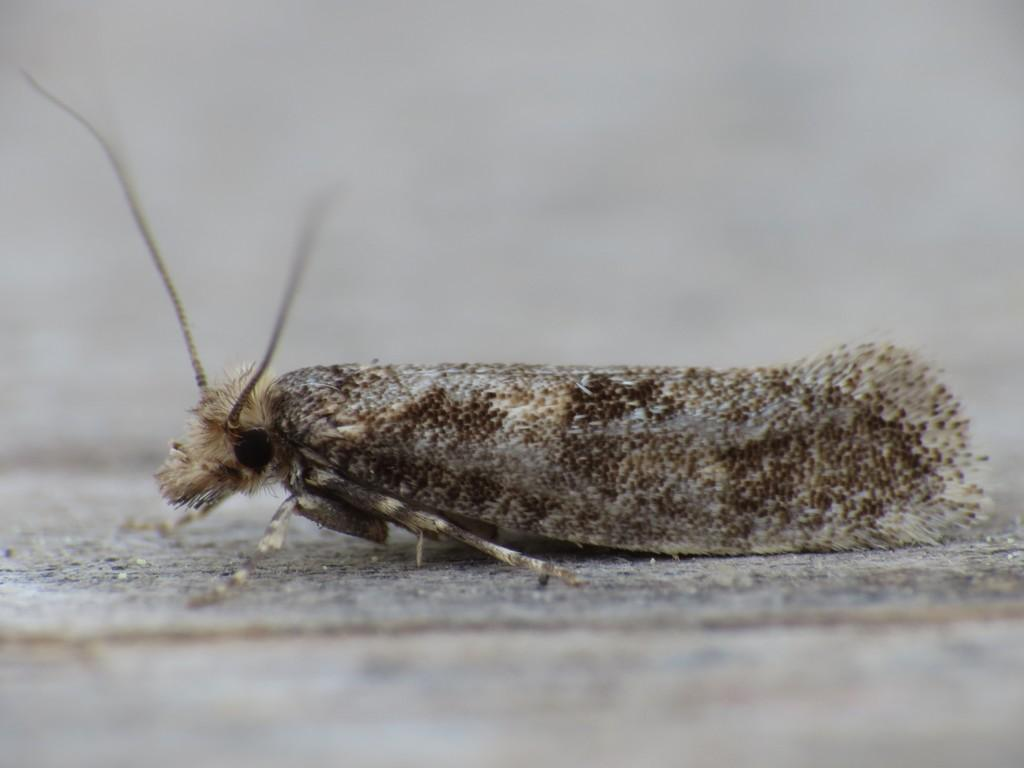What type of creature can be seen in the image? There is an insect in the image. Where is the insect located? The insect is on a surface. What type of stocking is the insect wearing in the image? There is no stocking present in the image, and insects do not wear clothing. 